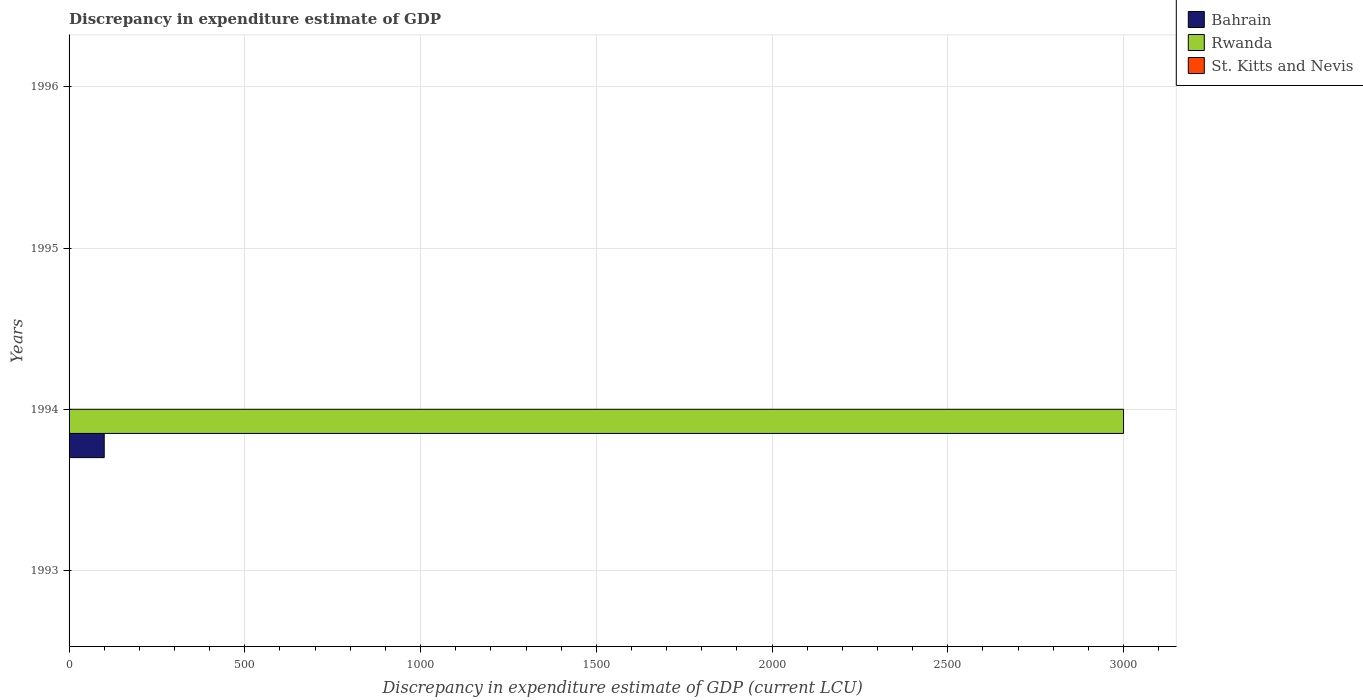How many different coloured bars are there?
Make the answer very short. 3. Are the number of bars per tick equal to the number of legend labels?
Keep it short and to the point. No. Are the number of bars on each tick of the Y-axis equal?
Keep it short and to the point. No. Across all years, what is the maximum discrepancy in expenditure estimate of GDP in Rwanda?
Offer a terse response. 3000. Across all years, what is the minimum discrepancy in expenditure estimate of GDP in St. Kitts and Nevis?
Give a very brief answer. 0. In which year was the discrepancy in expenditure estimate of GDP in Bahrain maximum?
Offer a terse response. 1994. What is the total discrepancy in expenditure estimate of GDP in Rwanda in the graph?
Offer a very short reply. 3000. What is the difference between the discrepancy in expenditure estimate of GDP in St. Kitts and Nevis in 1995 and that in 1996?
Make the answer very short. -1.7999999999999997e-7. What is the difference between the discrepancy in expenditure estimate of GDP in Rwanda in 1994 and the discrepancy in expenditure estimate of GDP in St. Kitts and Nevis in 1995?
Your response must be concise. 3000. What is the average discrepancy in expenditure estimate of GDP in Bahrain per year?
Give a very brief answer. 25. In the year 1996, what is the difference between the discrepancy in expenditure estimate of GDP in St. Kitts and Nevis and discrepancy in expenditure estimate of GDP in Bahrain?
Provide a succinct answer. 1.7999999999999997e-7. What is the ratio of the discrepancy in expenditure estimate of GDP in Bahrain in 1994 to that in 1996?
Your answer should be compact. 1.67e+09. What is the difference between the highest and the second highest discrepancy in expenditure estimate of GDP in St. Kitts and Nevis?
Ensure brevity in your answer.  1.7999999999999997e-7. What is the difference between the highest and the lowest discrepancy in expenditure estimate of GDP in Rwanda?
Keep it short and to the point. 3000. How many bars are there?
Your response must be concise. 6. Does the graph contain any zero values?
Ensure brevity in your answer.  Yes. Does the graph contain grids?
Your response must be concise. Yes. What is the title of the graph?
Your response must be concise. Discrepancy in expenditure estimate of GDP. What is the label or title of the X-axis?
Offer a very short reply. Discrepancy in expenditure estimate of GDP (current LCU). What is the Discrepancy in expenditure estimate of GDP (current LCU) in Bahrain in 1993?
Keep it short and to the point. 0. What is the Discrepancy in expenditure estimate of GDP (current LCU) in Rwanda in 1993?
Provide a succinct answer. 0. What is the Discrepancy in expenditure estimate of GDP (current LCU) in St. Kitts and Nevis in 1993?
Your response must be concise. 3e-8. What is the Discrepancy in expenditure estimate of GDP (current LCU) in Bahrain in 1994?
Provide a succinct answer. 100. What is the Discrepancy in expenditure estimate of GDP (current LCU) of Rwanda in 1994?
Your answer should be compact. 3000. What is the Discrepancy in expenditure estimate of GDP (current LCU) in Bahrain in 1995?
Your response must be concise. 0. What is the Discrepancy in expenditure estimate of GDP (current LCU) of Rwanda in 1995?
Provide a succinct answer. 0. What is the Discrepancy in expenditure estimate of GDP (current LCU) of St. Kitts and Nevis in 1995?
Your answer should be compact. 6e-8. What is the Discrepancy in expenditure estimate of GDP (current LCU) of Bahrain in 1996?
Make the answer very short. 6e-8. What is the Discrepancy in expenditure estimate of GDP (current LCU) of Rwanda in 1996?
Offer a very short reply. 0. What is the Discrepancy in expenditure estimate of GDP (current LCU) of St. Kitts and Nevis in 1996?
Provide a succinct answer. 2.4e-7. Across all years, what is the maximum Discrepancy in expenditure estimate of GDP (current LCU) in Bahrain?
Your answer should be compact. 100. Across all years, what is the maximum Discrepancy in expenditure estimate of GDP (current LCU) of Rwanda?
Give a very brief answer. 3000. Across all years, what is the maximum Discrepancy in expenditure estimate of GDP (current LCU) in St. Kitts and Nevis?
Your answer should be very brief. 2.4e-7. Across all years, what is the minimum Discrepancy in expenditure estimate of GDP (current LCU) of Rwanda?
Give a very brief answer. 0. Across all years, what is the minimum Discrepancy in expenditure estimate of GDP (current LCU) of St. Kitts and Nevis?
Keep it short and to the point. 0. What is the total Discrepancy in expenditure estimate of GDP (current LCU) of Bahrain in the graph?
Your answer should be very brief. 100. What is the total Discrepancy in expenditure estimate of GDP (current LCU) in Rwanda in the graph?
Offer a very short reply. 3000. What is the difference between the Discrepancy in expenditure estimate of GDP (current LCU) of St. Kitts and Nevis in 1993 and that in 1996?
Make the answer very short. -0. What is the difference between the Discrepancy in expenditure estimate of GDP (current LCU) of Rwanda in 1994 and the Discrepancy in expenditure estimate of GDP (current LCU) of St. Kitts and Nevis in 1995?
Provide a short and direct response. 3000. What is the difference between the Discrepancy in expenditure estimate of GDP (current LCU) in Bahrain in 1994 and the Discrepancy in expenditure estimate of GDP (current LCU) in St. Kitts and Nevis in 1996?
Keep it short and to the point. 100. What is the difference between the Discrepancy in expenditure estimate of GDP (current LCU) of Rwanda in 1994 and the Discrepancy in expenditure estimate of GDP (current LCU) of St. Kitts and Nevis in 1996?
Keep it short and to the point. 3000. What is the average Discrepancy in expenditure estimate of GDP (current LCU) in Bahrain per year?
Your answer should be very brief. 25. What is the average Discrepancy in expenditure estimate of GDP (current LCU) of Rwanda per year?
Make the answer very short. 750. What is the average Discrepancy in expenditure estimate of GDP (current LCU) of St. Kitts and Nevis per year?
Give a very brief answer. 0. In the year 1994, what is the difference between the Discrepancy in expenditure estimate of GDP (current LCU) in Bahrain and Discrepancy in expenditure estimate of GDP (current LCU) in Rwanda?
Offer a very short reply. -2900. What is the ratio of the Discrepancy in expenditure estimate of GDP (current LCU) in St. Kitts and Nevis in 1993 to that in 1996?
Your answer should be very brief. 0.12. What is the ratio of the Discrepancy in expenditure estimate of GDP (current LCU) in Bahrain in 1994 to that in 1996?
Give a very brief answer. 1.67e+09. What is the difference between the highest and the lowest Discrepancy in expenditure estimate of GDP (current LCU) in Bahrain?
Keep it short and to the point. 100. What is the difference between the highest and the lowest Discrepancy in expenditure estimate of GDP (current LCU) in Rwanda?
Your response must be concise. 3000. 